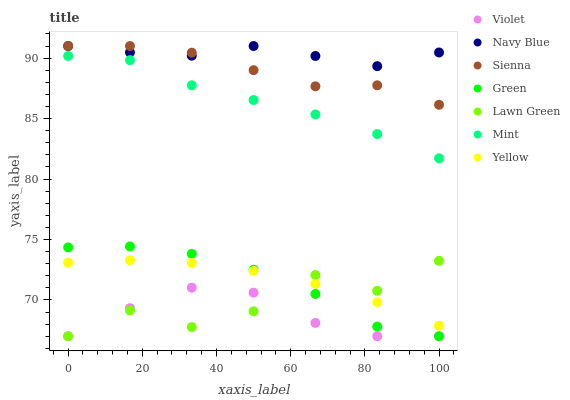Does Violet have the minimum area under the curve?
Answer yes or no. Yes. Does Navy Blue have the maximum area under the curve?
Answer yes or no. Yes. Does Yellow have the minimum area under the curve?
Answer yes or no. No. Does Yellow have the maximum area under the curve?
Answer yes or no. No. Is Yellow the smoothest?
Answer yes or no. Yes. Is Lawn Green the roughest?
Answer yes or no. Yes. Is Navy Blue the smoothest?
Answer yes or no. No. Is Navy Blue the roughest?
Answer yes or no. No. Does Lawn Green have the lowest value?
Answer yes or no. Yes. Does Yellow have the lowest value?
Answer yes or no. No. Does Sienna have the highest value?
Answer yes or no. Yes. Does Yellow have the highest value?
Answer yes or no. No. Is Yellow less than Mint?
Answer yes or no. Yes. Is Navy Blue greater than Lawn Green?
Answer yes or no. Yes. Does Yellow intersect Green?
Answer yes or no. Yes. Is Yellow less than Green?
Answer yes or no. No. Is Yellow greater than Green?
Answer yes or no. No. Does Yellow intersect Mint?
Answer yes or no. No. 